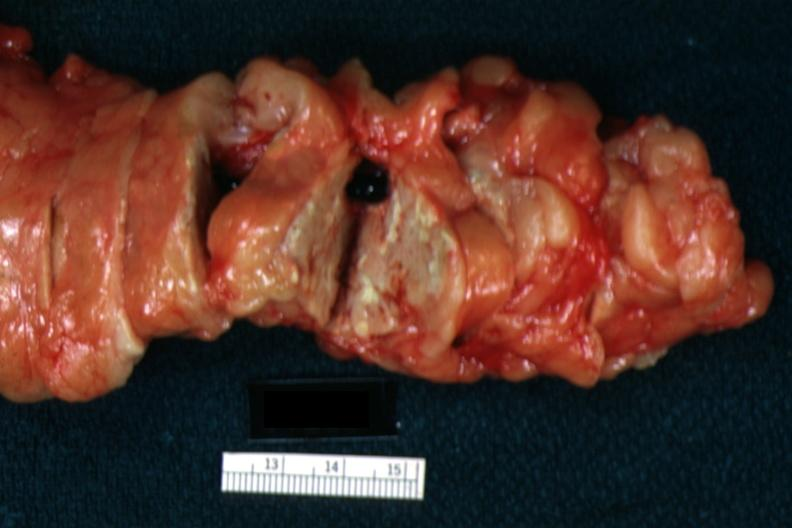s shock present?
Answer the question using a single word or phrase. Yes 